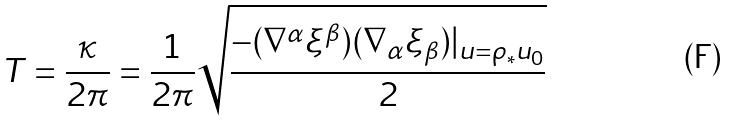<formula> <loc_0><loc_0><loc_500><loc_500>T = \frac { \kappa } { 2 \pi } = \frac { 1 } { 2 \pi } \sqrt { \frac { - ( \nabla ^ { \alpha } \xi ^ { \beta } ) ( \nabla _ { \alpha } \xi _ { \beta } ) | _ { u = \rho _ { * } u _ { 0 } } } { 2 } }</formula> 